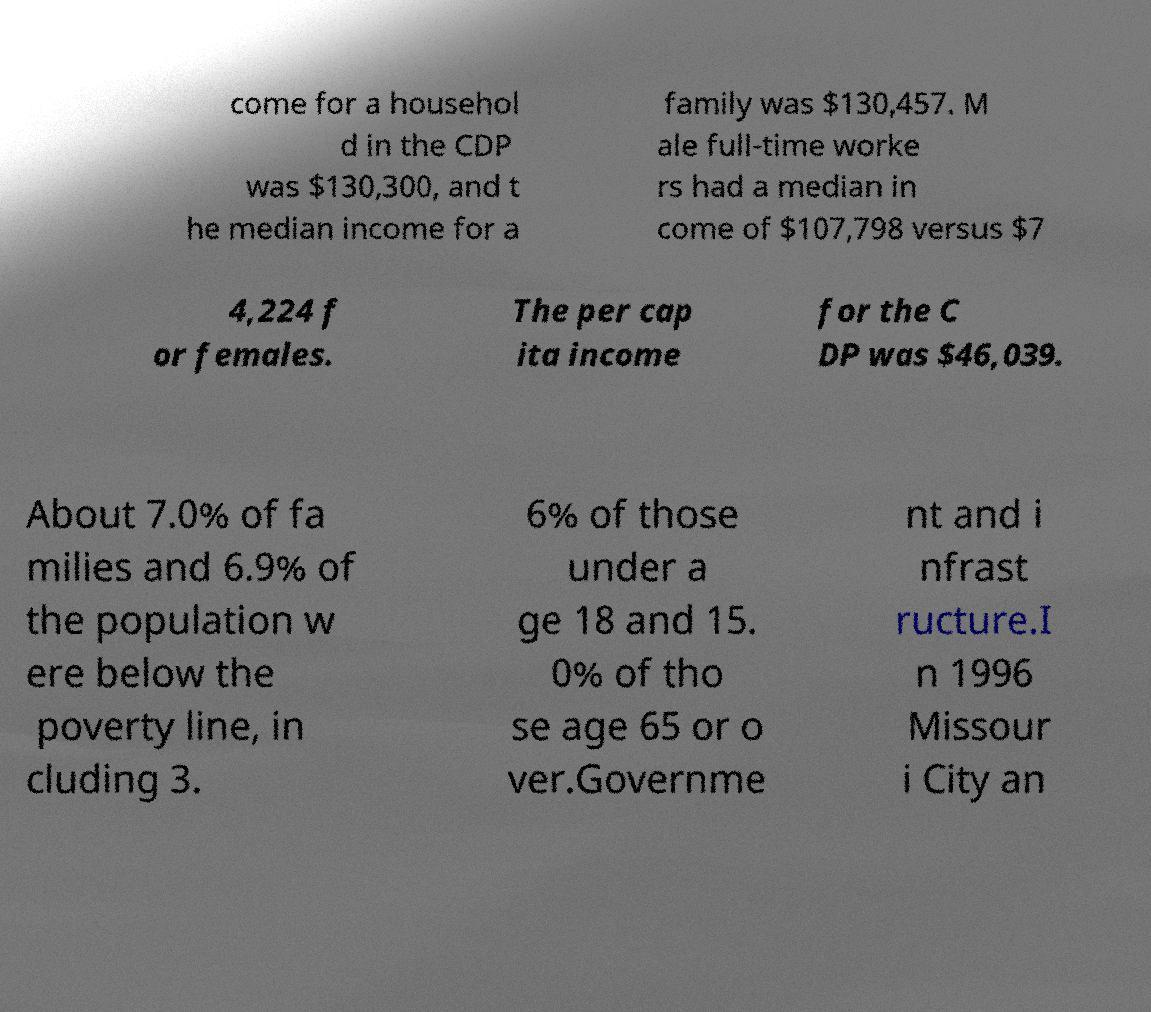For documentation purposes, I need the text within this image transcribed. Could you provide that? come for a househol d in the CDP was $130,300, and t he median income for a family was $130,457. M ale full-time worke rs had a median in come of $107,798 versus $7 4,224 f or females. The per cap ita income for the C DP was $46,039. About 7.0% of fa milies and 6.9% of the population w ere below the poverty line, in cluding 3. 6% of those under a ge 18 and 15. 0% of tho se age 65 or o ver.Governme nt and i nfrast ructure.I n 1996 Missour i City an 